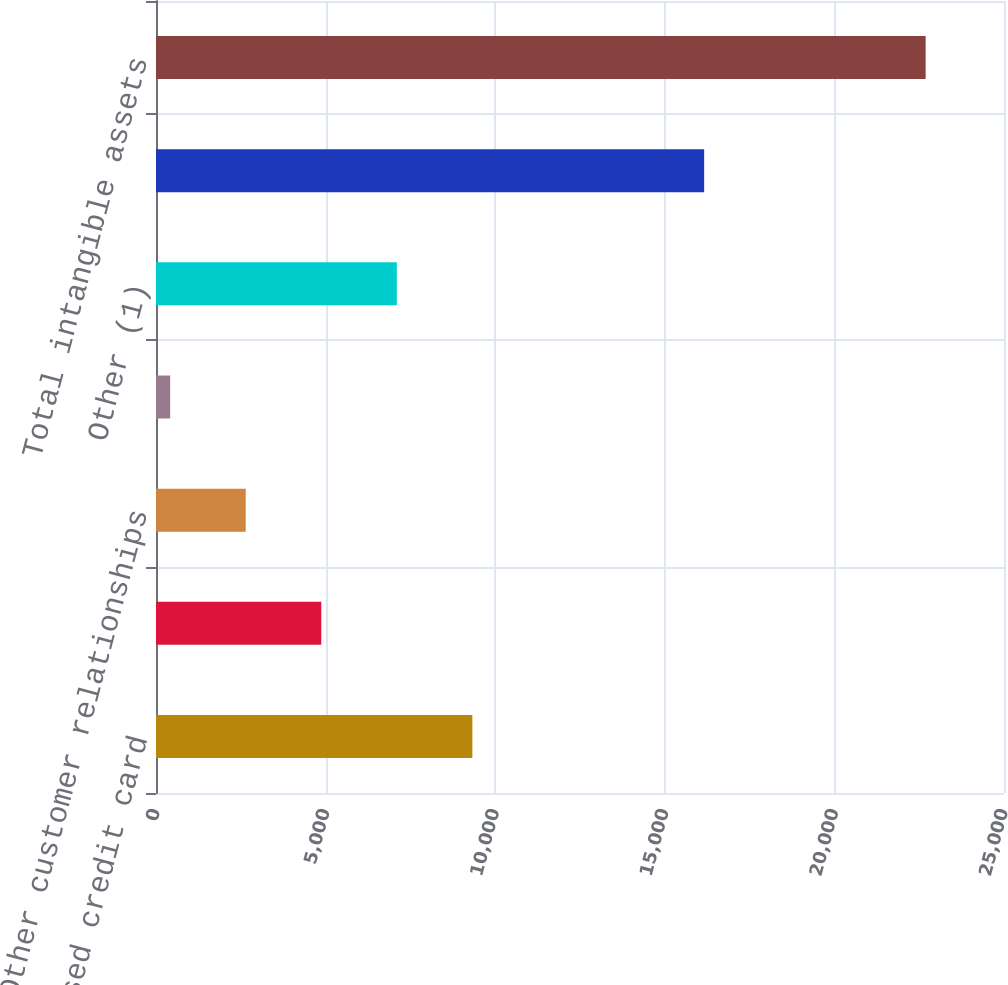Convert chart. <chart><loc_0><loc_0><loc_500><loc_500><bar_chart><fcel>Purchased credit card<fcel>Core deposit intangibles<fcel>Other customer relationships<fcel>Present value of future<fcel>Other (1)<fcel>Intangible assets (excluding<fcel>Total intangible assets<nl><fcel>9326.8<fcel>4872.4<fcel>2645.2<fcel>418<fcel>7099.6<fcel>16160<fcel>22690<nl></chart> 